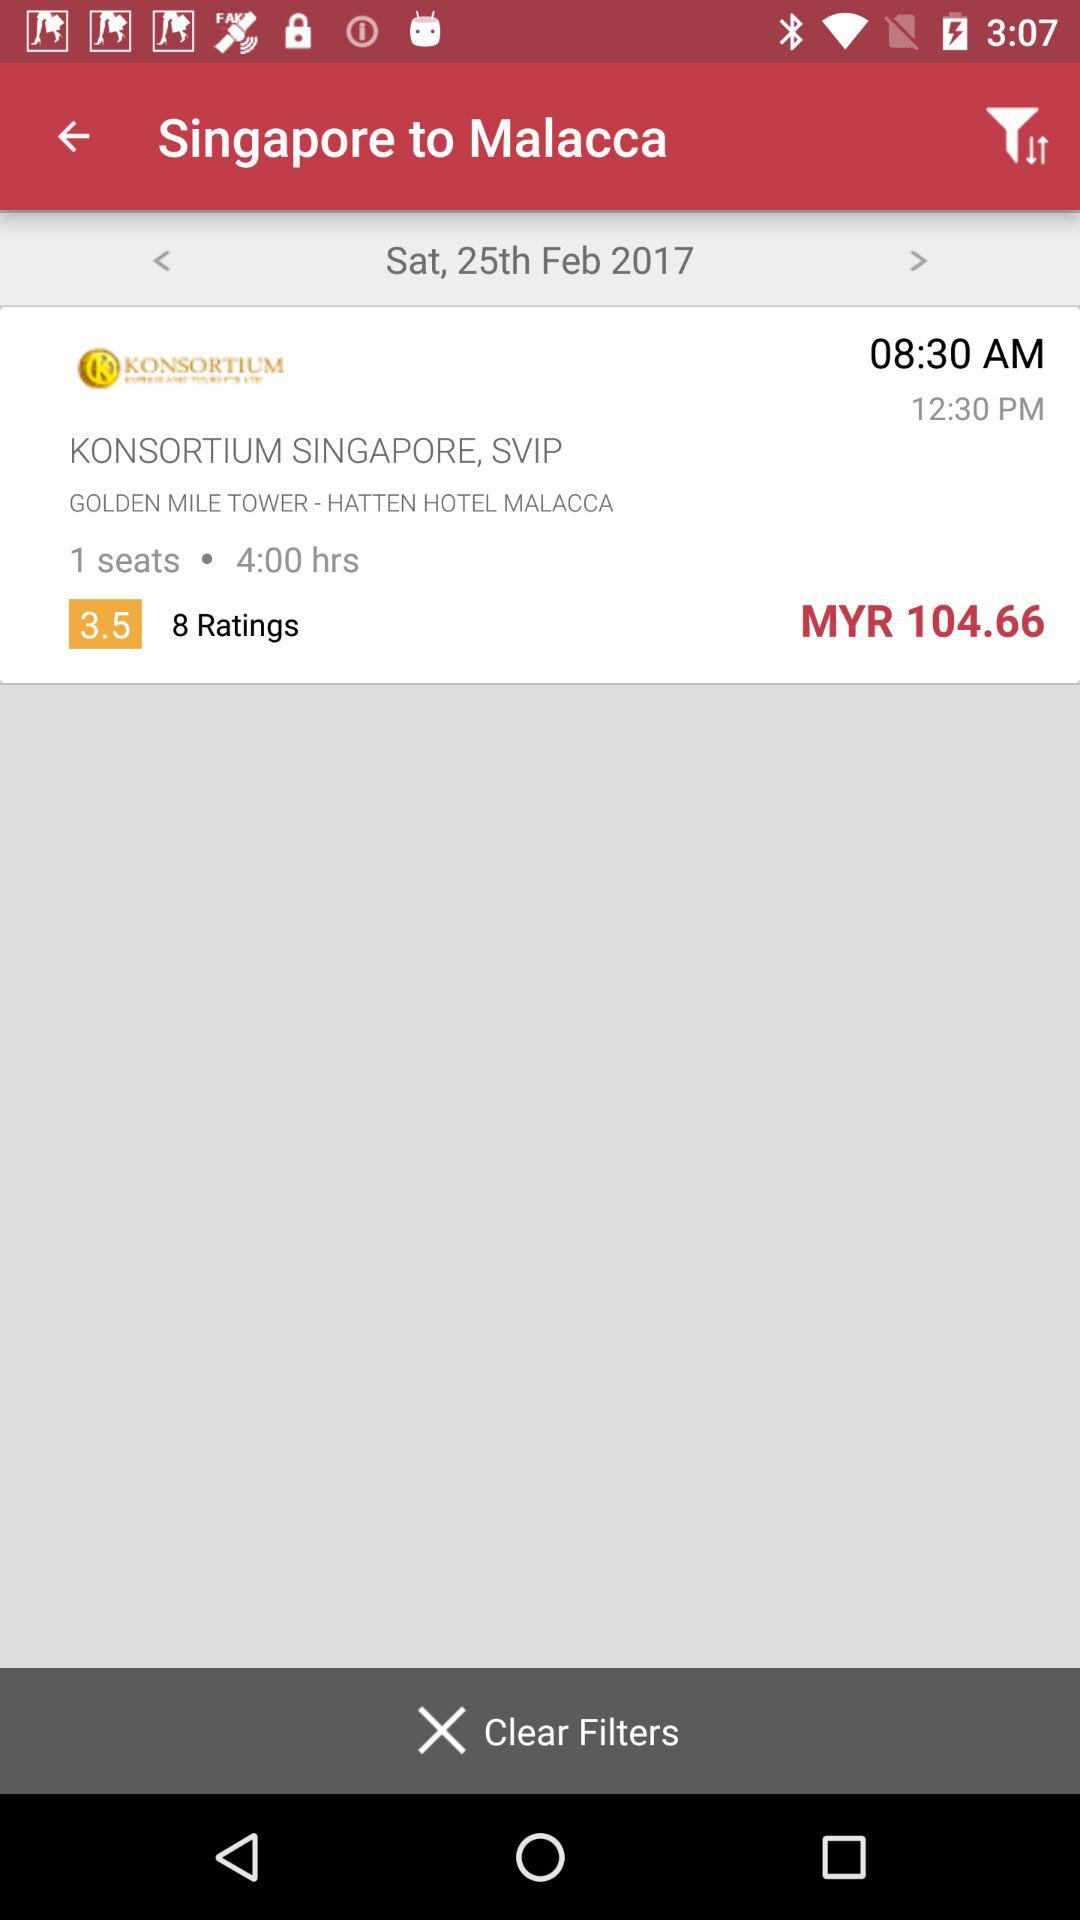What is the date? The date is February 25, 2017. 